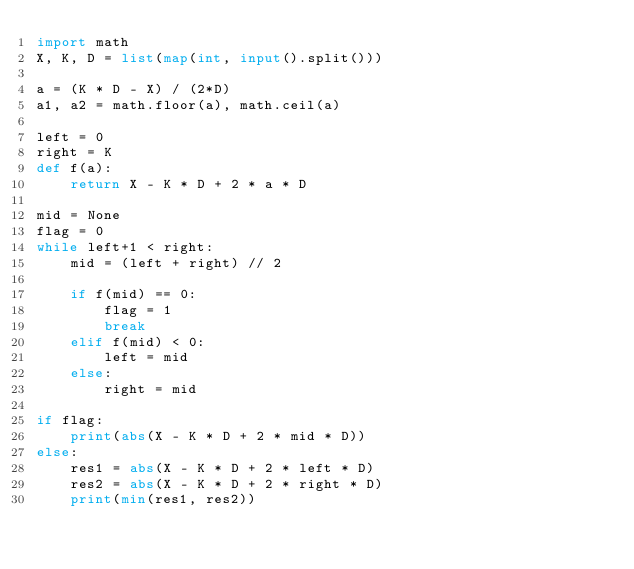Convert code to text. <code><loc_0><loc_0><loc_500><loc_500><_Python_>import math
X, K, D = list(map(int, input().split()))

a = (K * D - X) / (2*D)
a1, a2 = math.floor(a), math.ceil(a)

left = 0
right = K
def f(a):
    return X - K * D + 2 * a * D

mid = None
flag = 0
while left+1 < right:
    mid = (left + right) // 2

    if f(mid) == 0:
        flag = 1
        break
    elif f(mid) < 0:
        left = mid
    else:
        right = mid

if flag:
    print(abs(X - K * D + 2 * mid * D))
else:
    res1 = abs(X - K * D + 2 * left * D)
    res2 = abs(X - K * D + 2 * right * D)
    print(min(res1, res2))
</code> 